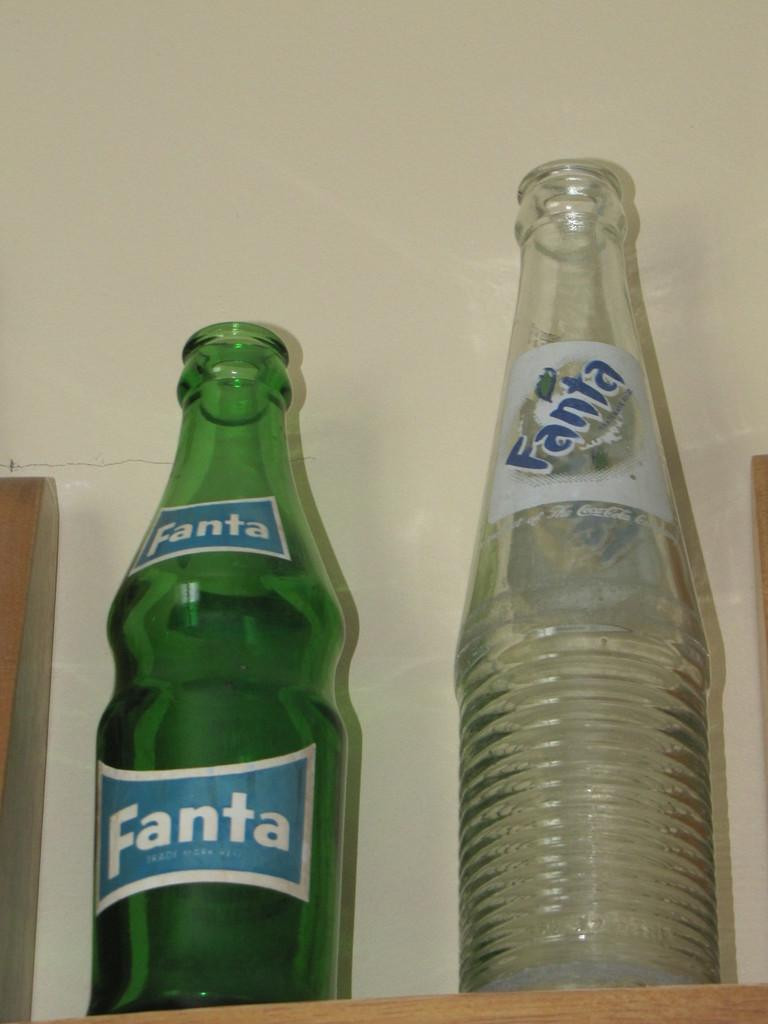<image>
Describe the image concisely. Left side tall green bottle with the words Fanta in a white bordered blue label. 